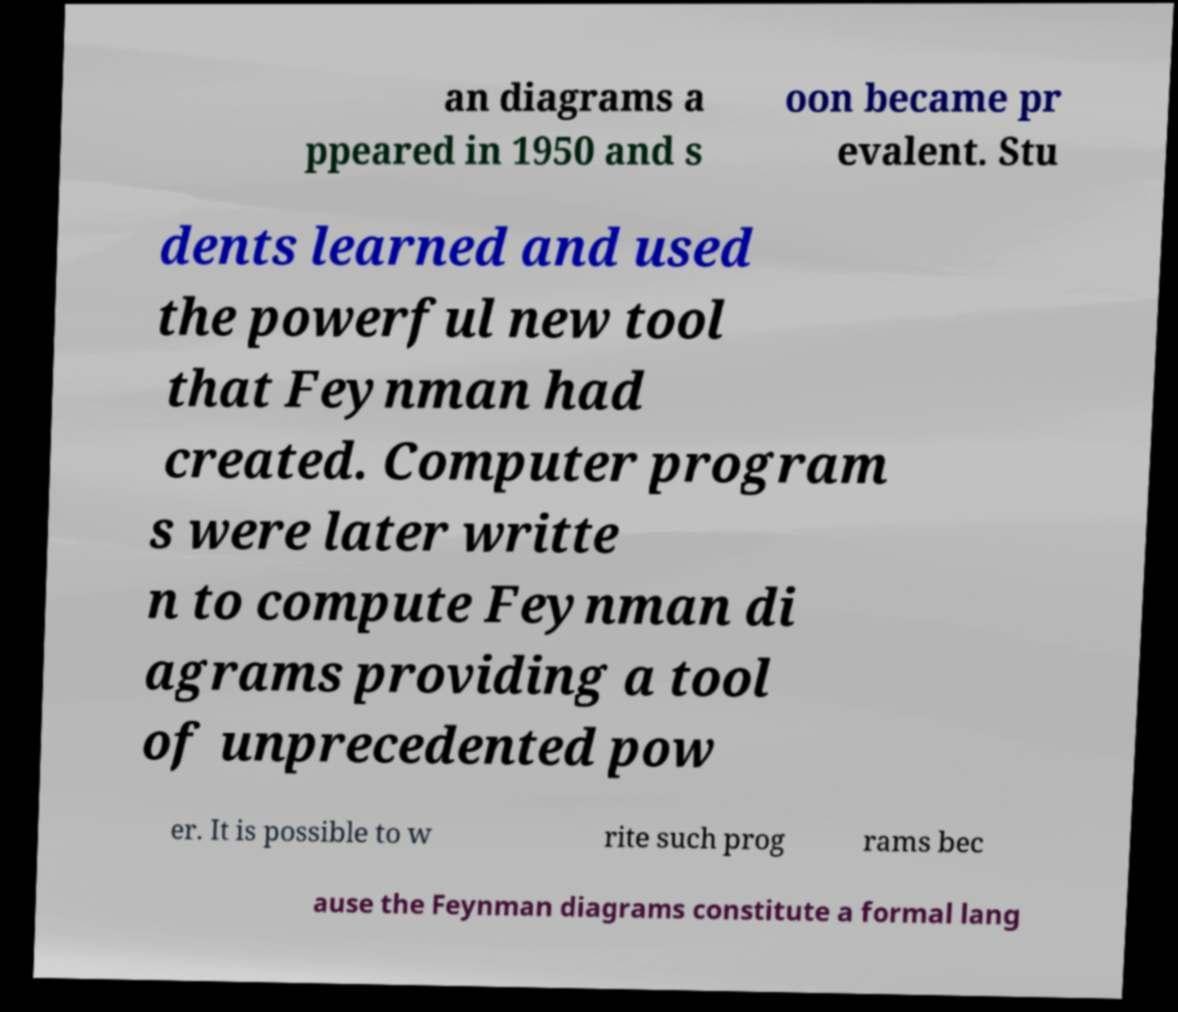Could you extract and type out the text from this image? an diagrams a ppeared in 1950 and s oon became pr evalent. Stu dents learned and used the powerful new tool that Feynman had created. Computer program s were later writte n to compute Feynman di agrams providing a tool of unprecedented pow er. It is possible to w rite such prog rams bec ause the Feynman diagrams constitute a formal lang 